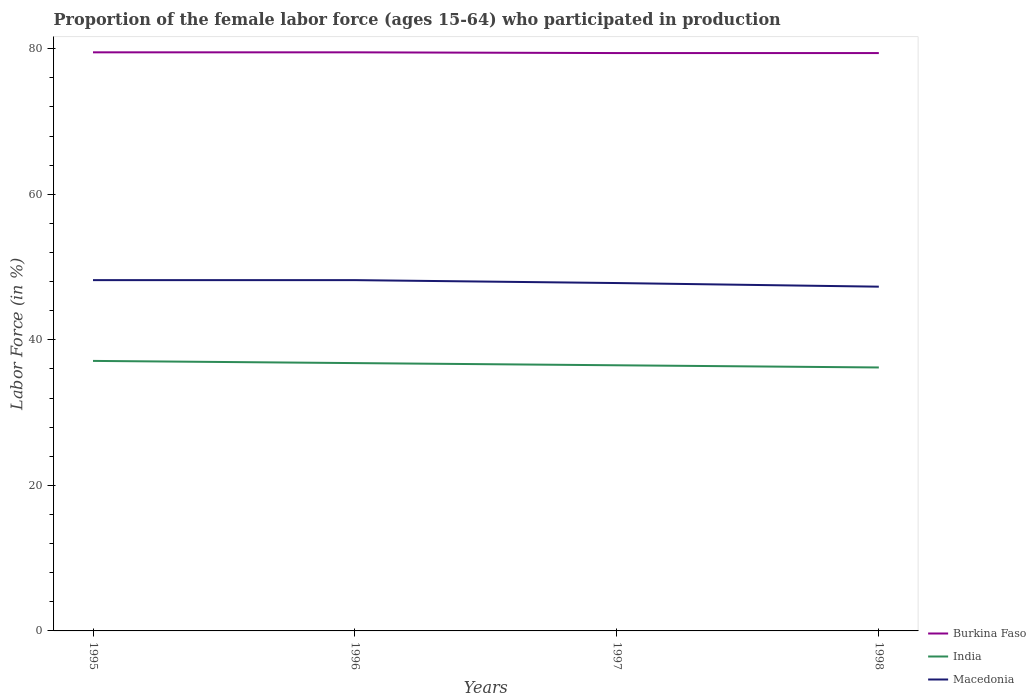How many different coloured lines are there?
Offer a very short reply. 3. Does the line corresponding to Burkina Faso intersect with the line corresponding to India?
Offer a very short reply. No. Is the number of lines equal to the number of legend labels?
Offer a very short reply. Yes. Across all years, what is the maximum proportion of the female labor force who participated in production in Macedonia?
Keep it short and to the point. 47.3. In which year was the proportion of the female labor force who participated in production in Macedonia maximum?
Make the answer very short. 1998. What is the difference between the highest and the second highest proportion of the female labor force who participated in production in Macedonia?
Your response must be concise. 0.9. How many lines are there?
Your answer should be compact. 3. How many years are there in the graph?
Give a very brief answer. 4. Are the values on the major ticks of Y-axis written in scientific E-notation?
Offer a terse response. No. Does the graph contain any zero values?
Your response must be concise. No. Does the graph contain grids?
Your answer should be compact. No. Where does the legend appear in the graph?
Your answer should be very brief. Bottom right. How many legend labels are there?
Make the answer very short. 3. How are the legend labels stacked?
Provide a succinct answer. Vertical. What is the title of the graph?
Give a very brief answer. Proportion of the female labor force (ages 15-64) who participated in production. What is the Labor Force (in %) of Burkina Faso in 1995?
Your answer should be very brief. 79.5. What is the Labor Force (in %) of India in 1995?
Give a very brief answer. 37.1. What is the Labor Force (in %) in Macedonia in 1995?
Offer a very short reply. 48.2. What is the Labor Force (in %) in Burkina Faso in 1996?
Ensure brevity in your answer.  79.5. What is the Labor Force (in %) in India in 1996?
Your answer should be compact. 36.8. What is the Labor Force (in %) in Macedonia in 1996?
Give a very brief answer. 48.2. What is the Labor Force (in %) in Burkina Faso in 1997?
Give a very brief answer. 79.4. What is the Labor Force (in %) of India in 1997?
Keep it short and to the point. 36.5. What is the Labor Force (in %) in Macedonia in 1997?
Provide a short and direct response. 47.8. What is the Labor Force (in %) in Burkina Faso in 1998?
Keep it short and to the point. 79.4. What is the Labor Force (in %) of India in 1998?
Your answer should be very brief. 36.2. What is the Labor Force (in %) in Macedonia in 1998?
Offer a terse response. 47.3. Across all years, what is the maximum Labor Force (in %) of Burkina Faso?
Your answer should be very brief. 79.5. Across all years, what is the maximum Labor Force (in %) of India?
Offer a very short reply. 37.1. Across all years, what is the maximum Labor Force (in %) in Macedonia?
Provide a succinct answer. 48.2. Across all years, what is the minimum Labor Force (in %) in Burkina Faso?
Keep it short and to the point. 79.4. Across all years, what is the minimum Labor Force (in %) of India?
Your response must be concise. 36.2. Across all years, what is the minimum Labor Force (in %) in Macedonia?
Provide a succinct answer. 47.3. What is the total Labor Force (in %) of Burkina Faso in the graph?
Your response must be concise. 317.8. What is the total Labor Force (in %) in India in the graph?
Offer a very short reply. 146.6. What is the total Labor Force (in %) in Macedonia in the graph?
Your response must be concise. 191.5. What is the difference between the Labor Force (in %) of Burkina Faso in 1995 and that in 1996?
Provide a succinct answer. 0. What is the difference between the Labor Force (in %) of India in 1995 and that in 1996?
Your answer should be very brief. 0.3. What is the difference between the Labor Force (in %) in Burkina Faso in 1995 and that in 1997?
Your response must be concise. 0.1. What is the difference between the Labor Force (in %) of Burkina Faso in 1995 and that in 1998?
Offer a very short reply. 0.1. What is the difference between the Labor Force (in %) of Macedonia in 1995 and that in 1998?
Make the answer very short. 0.9. What is the difference between the Labor Force (in %) in Burkina Faso in 1996 and that in 1997?
Your response must be concise. 0.1. What is the difference between the Labor Force (in %) of India in 1996 and that in 1997?
Provide a short and direct response. 0.3. What is the difference between the Labor Force (in %) of India in 1996 and that in 1998?
Offer a very short reply. 0.6. What is the difference between the Labor Force (in %) of Burkina Faso in 1997 and that in 1998?
Offer a very short reply. 0. What is the difference between the Labor Force (in %) of India in 1997 and that in 1998?
Offer a terse response. 0.3. What is the difference between the Labor Force (in %) in Burkina Faso in 1995 and the Labor Force (in %) in India in 1996?
Your response must be concise. 42.7. What is the difference between the Labor Force (in %) of Burkina Faso in 1995 and the Labor Force (in %) of Macedonia in 1996?
Offer a very short reply. 31.3. What is the difference between the Labor Force (in %) in India in 1995 and the Labor Force (in %) in Macedonia in 1996?
Make the answer very short. -11.1. What is the difference between the Labor Force (in %) of Burkina Faso in 1995 and the Labor Force (in %) of India in 1997?
Your response must be concise. 43. What is the difference between the Labor Force (in %) of Burkina Faso in 1995 and the Labor Force (in %) of Macedonia in 1997?
Provide a short and direct response. 31.7. What is the difference between the Labor Force (in %) of Burkina Faso in 1995 and the Labor Force (in %) of India in 1998?
Your answer should be very brief. 43.3. What is the difference between the Labor Force (in %) in Burkina Faso in 1995 and the Labor Force (in %) in Macedonia in 1998?
Provide a short and direct response. 32.2. What is the difference between the Labor Force (in %) of India in 1995 and the Labor Force (in %) of Macedonia in 1998?
Your response must be concise. -10.2. What is the difference between the Labor Force (in %) of Burkina Faso in 1996 and the Labor Force (in %) of India in 1997?
Your answer should be very brief. 43. What is the difference between the Labor Force (in %) in Burkina Faso in 1996 and the Labor Force (in %) in Macedonia in 1997?
Keep it short and to the point. 31.7. What is the difference between the Labor Force (in %) of Burkina Faso in 1996 and the Labor Force (in %) of India in 1998?
Offer a very short reply. 43.3. What is the difference between the Labor Force (in %) of Burkina Faso in 1996 and the Labor Force (in %) of Macedonia in 1998?
Your answer should be compact. 32.2. What is the difference between the Labor Force (in %) in India in 1996 and the Labor Force (in %) in Macedonia in 1998?
Offer a terse response. -10.5. What is the difference between the Labor Force (in %) of Burkina Faso in 1997 and the Labor Force (in %) of India in 1998?
Provide a short and direct response. 43.2. What is the difference between the Labor Force (in %) of Burkina Faso in 1997 and the Labor Force (in %) of Macedonia in 1998?
Your answer should be very brief. 32.1. What is the difference between the Labor Force (in %) in India in 1997 and the Labor Force (in %) in Macedonia in 1998?
Offer a terse response. -10.8. What is the average Labor Force (in %) in Burkina Faso per year?
Your response must be concise. 79.45. What is the average Labor Force (in %) in India per year?
Make the answer very short. 36.65. What is the average Labor Force (in %) of Macedonia per year?
Offer a very short reply. 47.88. In the year 1995, what is the difference between the Labor Force (in %) in Burkina Faso and Labor Force (in %) in India?
Make the answer very short. 42.4. In the year 1995, what is the difference between the Labor Force (in %) of Burkina Faso and Labor Force (in %) of Macedonia?
Ensure brevity in your answer.  31.3. In the year 1996, what is the difference between the Labor Force (in %) of Burkina Faso and Labor Force (in %) of India?
Offer a terse response. 42.7. In the year 1996, what is the difference between the Labor Force (in %) in Burkina Faso and Labor Force (in %) in Macedonia?
Offer a very short reply. 31.3. In the year 1997, what is the difference between the Labor Force (in %) in Burkina Faso and Labor Force (in %) in India?
Make the answer very short. 42.9. In the year 1997, what is the difference between the Labor Force (in %) of Burkina Faso and Labor Force (in %) of Macedonia?
Provide a short and direct response. 31.6. In the year 1997, what is the difference between the Labor Force (in %) of India and Labor Force (in %) of Macedonia?
Offer a terse response. -11.3. In the year 1998, what is the difference between the Labor Force (in %) in Burkina Faso and Labor Force (in %) in India?
Offer a terse response. 43.2. In the year 1998, what is the difference between the Labor Force (in %) of Burkina Faso and Labor Force (in %) of Macedonia?
Offer a terse response. 32.1. In the year 1998, what is the difference between the Labor Force (in %) of India and Labor Force (in %) of Macedonia?
Ensure brevity in your answer.  -11.1. What is the ratio of the Labor Force (in %) in India in 1995 to that in 1996?
Your answer should be very brief. 1.01. What is the ratio of the Labor Force (in %) of Macedonia in 1995 to that in 1996?
Give a very brief answer. 1. What is the ratio of the Labor Force (in %) in India in 1995 to that in 1997?
Give a very brief answer. 1.02. What is the ratio of the Labor Force (in %) in Macedonia in 1995 to that in 1997?
Provide a short and direct response. 1.01. What is the ratio of the Labor Force (in %) in India in 1995 to that in 1998?
Your answer should be very brief. 1.02. What is the ratio of the Labor Force (in %) of Macedonia in 1995 to that in 1998?
Give a very brief answer. 1.02. What is the ratio of the Labor Force (in %) of India in 1996 to that in 1997?
Give a very brief answer. 1.01. What is the ratio of the Labor Force (in %) of Macedonia in 1996 to that in 1997?
Your response must be concise. 1.01. What is the ratio of the Labor Force (in %) in India in 1996 to that in 1998?
Offer a terse response. 1.02. What is the ratio of the Labor Force (in %) in Macedonia in 1996 to that in 1998?
Your answer should be compact. 1.02. What is the ratio of the Labor Force (in %) of India in 1997 to that in 1998?
Make the answer very short. 1.01. What is the ratio of the Labor Force (in %) of Macedonia in 1997 to that in 1998?
Offer a terse response. 1.01. What is the difference between the highest and the second highest Labor Force (in %) in Burkina Faso?
Make the answer very short. 0. What is the difference between the highest and the second highest Labor Force (in %) in Macedonia?
Give a very brief answer. 0. What is the difference between the highest and the lowest Labor Force (in %) in Burkina Faso?
Offer a very short reply. 0.1. 